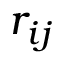<formula> <loc_0><loc_0><loc_500><loc_500>r _ { i j }</formula> 